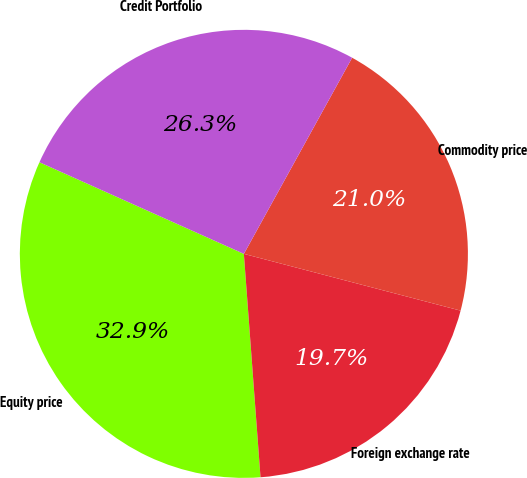Convert chart. <chart><loc_0><loc_0><loc_500><loc_500><pie_chart><fcel>Equity price<fcel>Foreign exchange rate<fcel>Commodity price<fcel>Credit Portfolio<nl><fcel>32.89%<fcel>19.74%<fcel>21.05%<fcel>26.32%<nl></chart> 